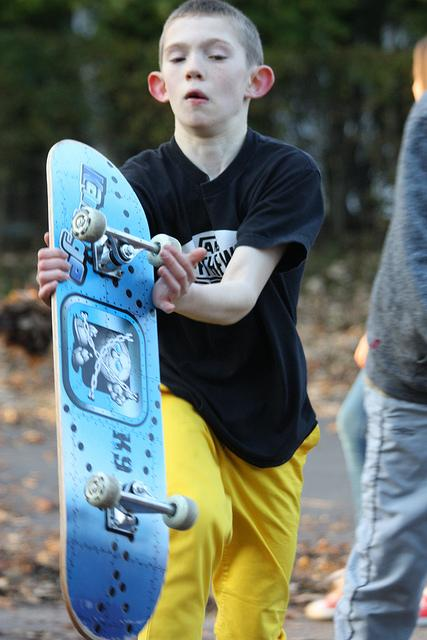What jungle animal do his ears resemble? monkey 